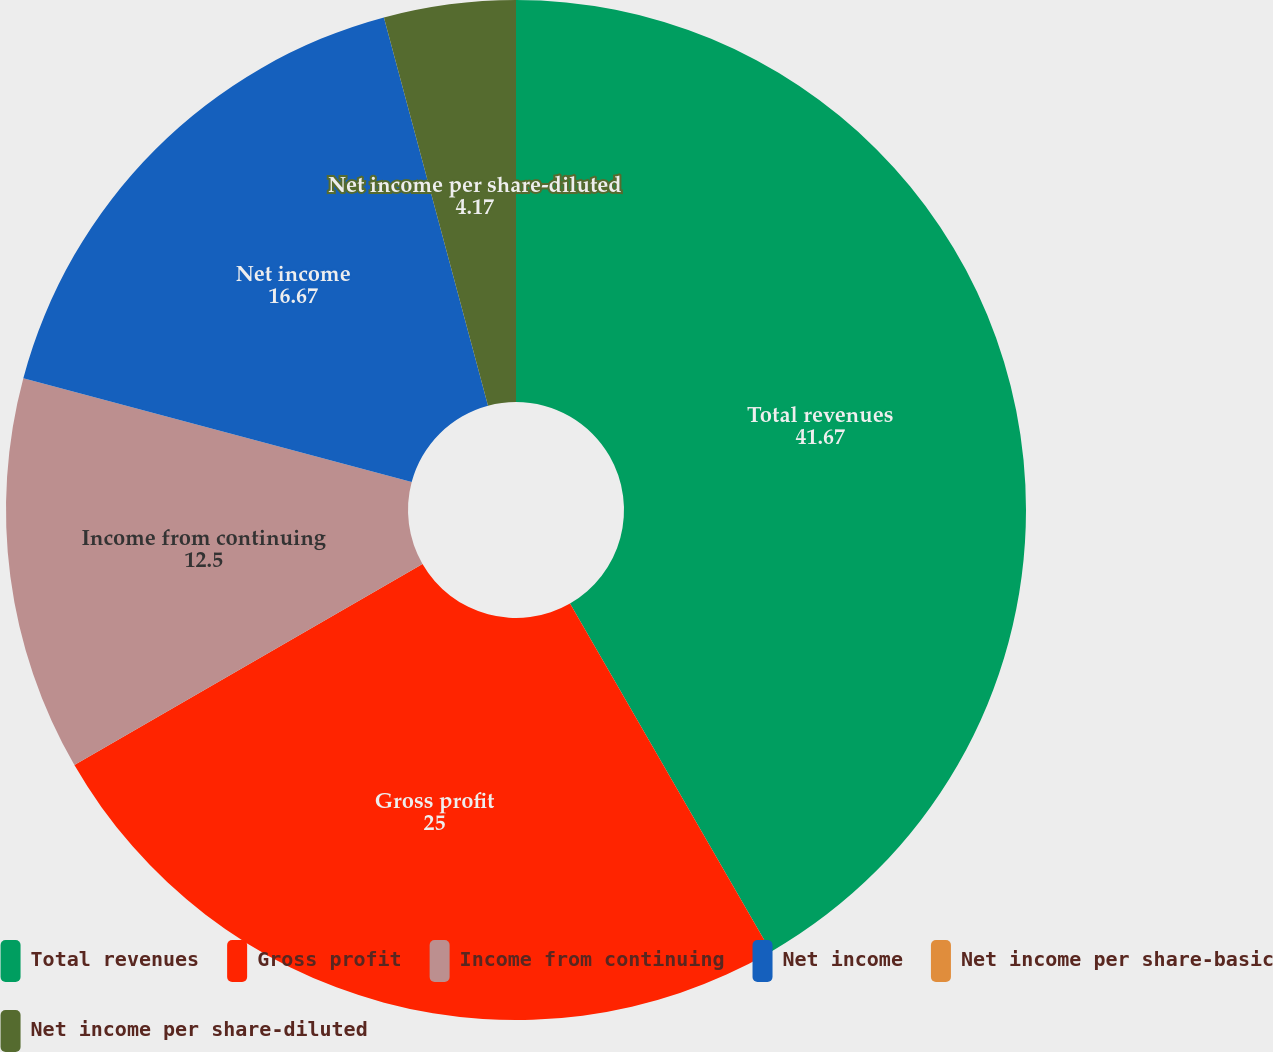Convert chart to OTSL. <chart><loc_0><loc_0><loc_500><loc_500><pie_chart><fcel>Total revenues<fcel>Gross profit<fcel>Income from continuing<fcel>Net income<fcel>Net income per share-basic<fcel>Net income per share-diluted<nl><fcel>41.67%<fcel>25.0%<fcel>12.5%<fcel>16.67%<fcel>0.0%<fcel>4.17%<nl></chart> 